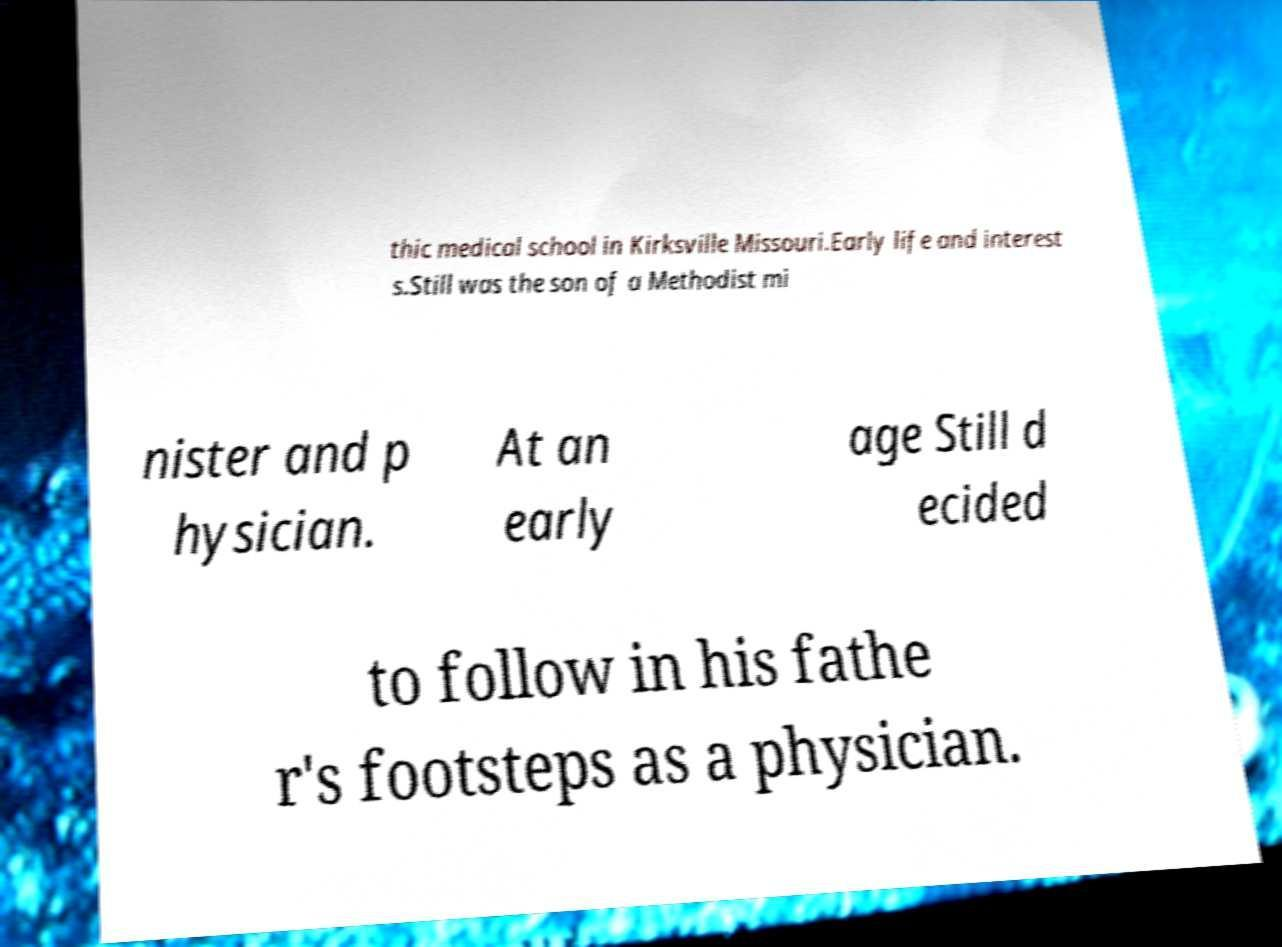Please read and relay the text visible in this image. What does it say? thic medical school in Kirksville Missouri.Early life and interest s.Still was the son of a Methodist mi nister and p hysician. At an early age Still d ecided to follow in his fathe r's footsteps as a physician. 